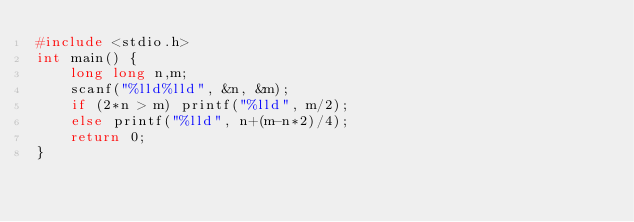<code> <loc_0><loc_0><loc_500><loc_500><_C_>#include <stdio.h>
int main() {
	long long n,m;
	scanf("%lld%lld", &n, &m);
	if (2*n > m) printf("%lld", m/2);
	else printf("%lld", n+(m-n*2)/4);
	return 0;
}
</code> 